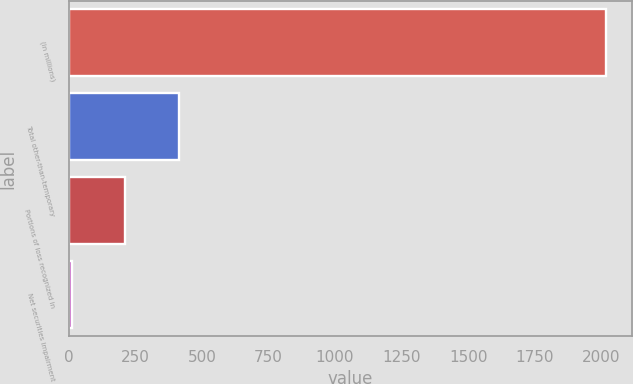Convert chart. <chart><loc_0><loc_0><loc_500><loc_500><bar_chart><fcel>(in millions)<fcel>Total other-than-temporary<fcel>Portions of loss recognized in<fcel>Net securities impairment<nl><fcel>2016<fcel>412.8<fcel>212.4<fcel>12<nl></chart> 